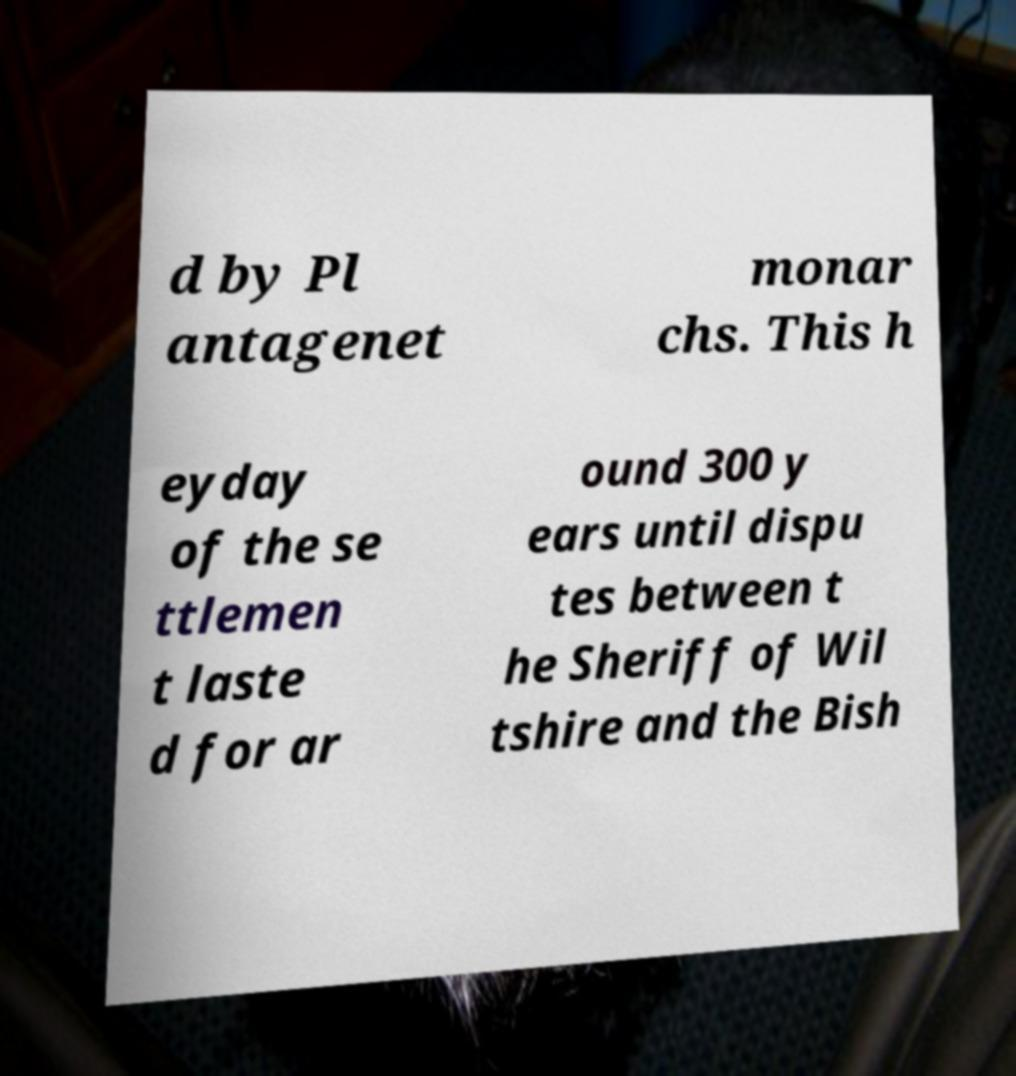Please read and relay the text visible in this image. What does it say? d by Pl antagenet monar chs. This h eyday of the se ttlemen t laste d for ar ound 300 y ears until dispu tes between t he Sheriff of Wil tshire and the Bish 